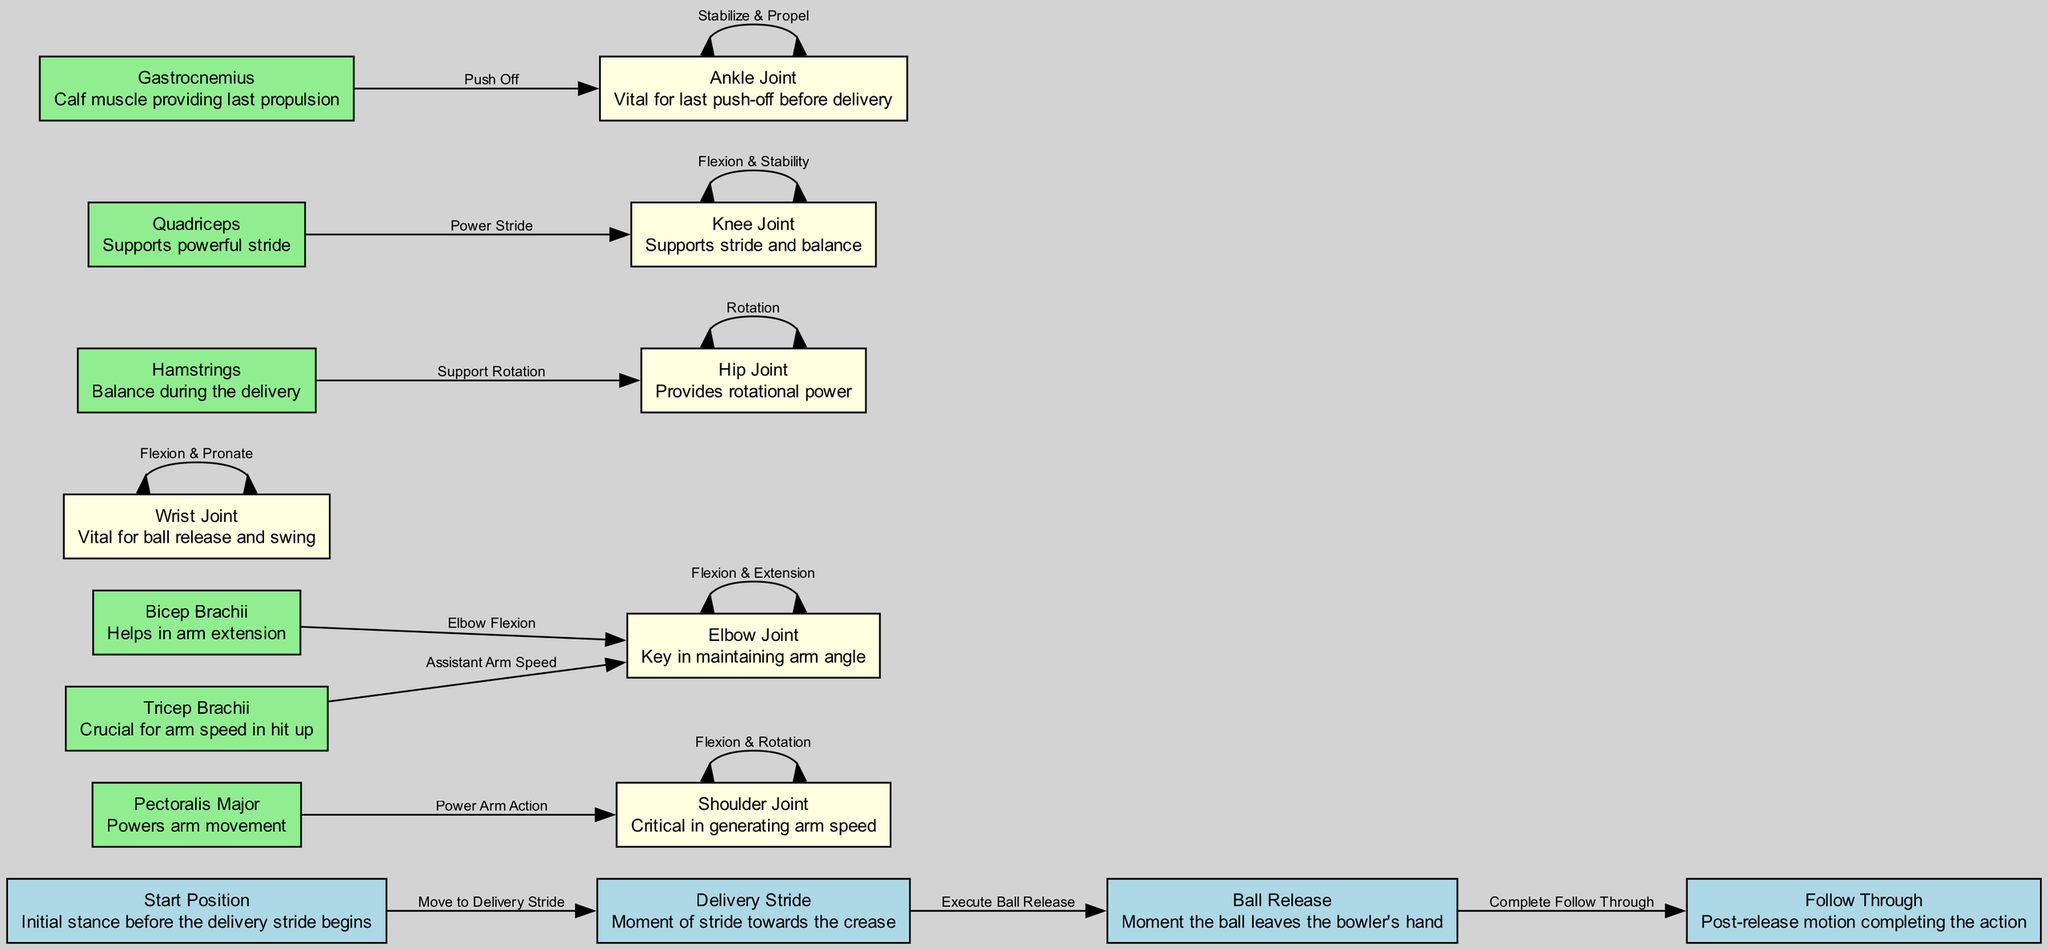What is the first step in the fast bowler’s action? The diagram indicates that the first step is the "Start Position," which is the initial stance before the delivery stride begins.
Answer: Start Position How many main phases are there in the bowler's action? By observing the nodes, there are four main phases: Start Position, Delivery Stride, Ball Release, and Follow Through.
Answer: Four Which joint is critical in generating arm speed? The diagram identifies the "Shoulder Joint" as critical for generating arm speed during the bowling action.
Answer: Shoulder Joint What muscle supports the powerful stride? The "Quadriceps" muscle, as indicated in the diagram, supports powerful stride during the bowler's action.
Answer: Quadriceps What is the relationship between the elbow joint and the bicep brachii? The diagram shows that the bicep brachii is responsible for "Elbow Flexion," a key action that influences the elbow joint's movement during the bowling action.
Answer: Elbow Flexion Which joint provides rotational power? According to the diagram, the "Hip Joint" is the joint that provides rotational power necessary for the bowling action.
Answer: Hip Joint What action is required after the ball release? Following the ball release, the bowler must complete the "Follow Through," a critical part of the bowling action to finish with balance and control.
Answer: Follow Through Explain the significance of the gastrocnemius muscle in the action. The gastrocnemius muscle is vital for providing the last propulsion before delivery and is connected to the ankle joint, which stabilizes and propels the body forward during release.
Answer: Last propulsion How does the tricep brachii assist in the bowling action? The tricep brachii plays an important role in providing "Assistant Arm Speed," which enhances the speed of the arm during the bowling action.
Answer: Assistant Arm Speed 